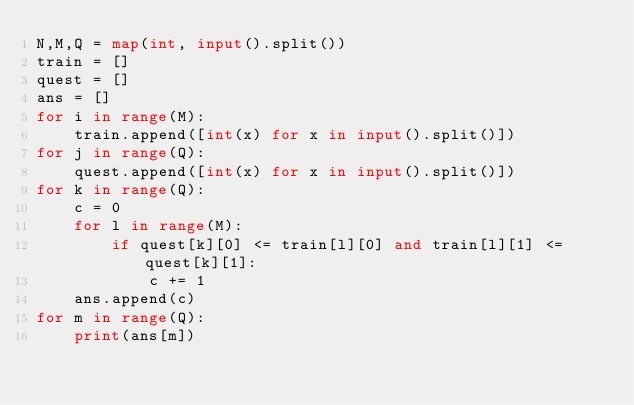<code> <loc_0><loc_0><loc_500><loc_500><_Python_>N,M,Q = map(int, input().split())
train = []
quest = []
ans = []
for i in range(M):
    train.append([int(x) for x in input().split()])
for j in range(Q):
    quest.append([int(x) for x in input().split()])
for k in range(Q):
    c = 0
    for l in range(M):
        if quest[k][0] <= train[l][0] and train[l][1] <= quest[k][1]:
            c += 1
    ans.append(c)
for m in range(Q):
    print(ans[m])</code> 